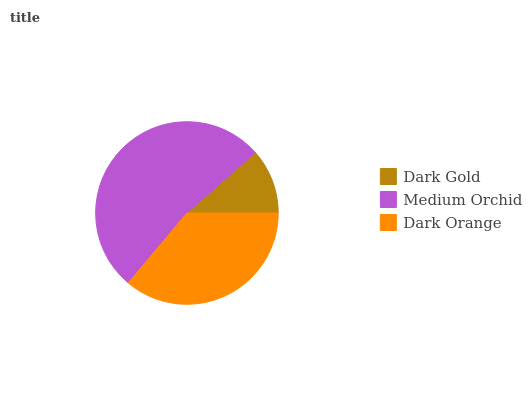Is Dark Gold the minimum?
Answer yes or no. Yes. Is Medium Orchid the maximum?
Answer yes or no. Yes. Is Dark Orange the minimum?
Answer yes or no. No. Is Dark Orange the maximum?
Answer yes or no. No. Is Medium Orchid greater than Dark Orange?
Answer yes or no. Yes. Is Dark Orange less than Medium Orchid?
Answer yes or no. Yes. Is Dark Orange greater than Medium Orchid?
Answer yes or no. No. Is Medium Orchid less than Dark Orange?
Answer yes or no. No. Is Dark Orange the high median?
Answer yes or no. Yes. Is Dark Orange the low median?
Answer yes or no. Yes. Is Medium Orchid the high median?
Answer yes or no. No. Is Medium Orchid the low median?
Answer yes or no. No. 